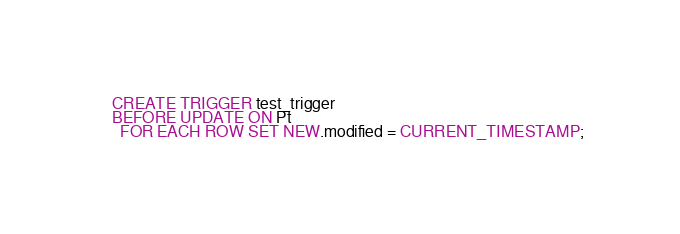Convert code to text. <code><loc_0><loc_0><loc_500><loc_500><_SQL_>CREATE TRIGGER test_trigger
BEFORE UPDATE ON Pt
  FOR EACH ROW SET NEW.modified = CURRENT_TIMESTAMP;</code> 